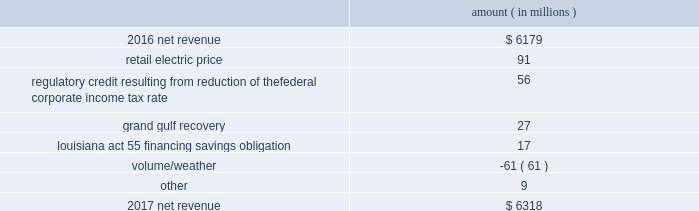Results of operations for 2016 include : 1 ) $ 2836 million ( $ 1829 million net-of-tax ) of impairment and related charges primarily to write down the carrying values of the entergy wholesale commodities 2019 palisades , indian point 2 , and indian point 3 plants and related assets to their fair values ; 2 ) a reduction of income tax expense , net of unrecognized tax benefits , of $ 238 million as a result of a change in the tax classification of a legal entity that owned one of the entergy wholesale commodities nuclear power plants ; income tax benefits as a result of the settlement of the 2010-2011 irs audit , including a $ 75 million tax benefit recognized by entergy louisiana related to the treatment of the vidalia purchased power agreement and a $ 54 million net benefit recognized by entergy louisiana related to the treatment of proceeds received in 2010 for the financing of hurricane gustav and hurricane ike storm costs pursuant to louisiana act 55 ; and 3 ) a reduction in expenses of $ 100 million ( $ 64 million net-of-tax ) due to the effects of recording in 2016 the final court decisions in several lawsuits against the doe related to spent nuclear fuel storage costs .
See note 14 to the financial statements for further discussion of the impairment and related charges , see note 3 to the financial statements for additional discussion of the income tax items , and see note 8 to the financial statements for discussion of the spent nuclear fuel litigation .
Net revenue utility following is an analysis of the change in net revenue comparing 2017 to 2016 .
Amount ( in millions ) .
The retail electric price variance is primarily due to : 2022 the implementation of formula rate plan rates effective with the first billing cycle of january 2017 at entergy arkansas and an increase in base rates effective february 24 , 2016 , each as approved by the apsc .
A significant portion of the base rate increase was related to the purchase of power block 2 of the union power station in march 2016 ; 2022 a provision recorded in 2016 related to the settlement of the waterford 3 replacement steam generator prudence review proceeding ; 2022 the implementation of the transmission cost recovery factor rider at entergy texas , effective september 2016 , and an increase in the transmission cost recovery factor rider rate , effective march 2017 , as approved by the puct ; and 2022 an increase in rates at entergy mississippi , as approved by the mpsc , effective with the first billing cycle of july 2016 .
See note 2 to the financial statements for further discussion of the rate proceedings and the waterford 3 replacement steam generator prudence review proceeding .
See note 14 to the financial statements for discussion of the union power station purchase .
Entergy corporation and subsidiaries management 2019s financial discussion and analysis .
What was the percent of the change in the net revenue from 2016 to 2017? 
Computations: ((6318 - 6179) / 6179)
Answer: 0.0225. 